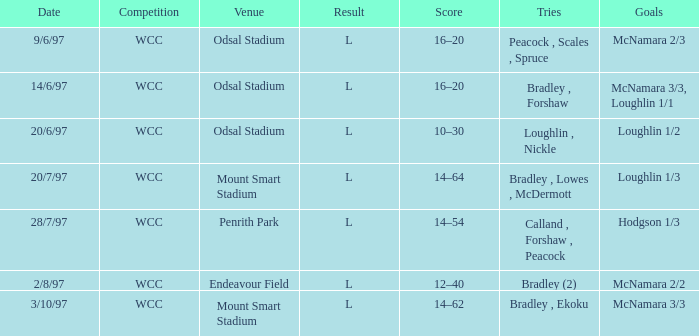What were the goals on 3/10/97? McNamara 3/3. 